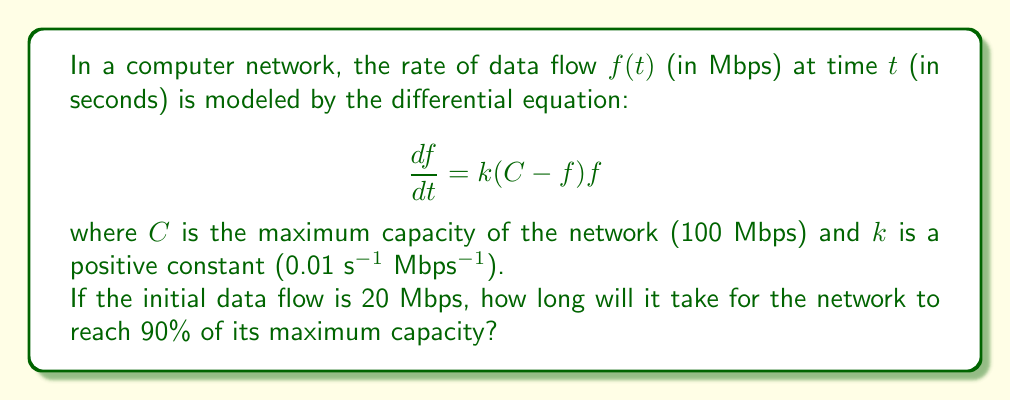Give your solution to this math problem. To solve this problem, we need to follow these steps:

1) First, we need to solve the differential equation. This is a logistic growth model.

2) The general solution to this equation is:

   $$f(t) = \frac{C}{1 + Ae^{-kCt}}$$

   where $A$ is a constant that depends on the initial condition.

3) We can find $A$ using the initial condition $f(0) = 20$:

   $$20 = \frac{100}{1 + A}$$
   $$A = 4$$

4) So our specific solution is:

   $$f(t) = \frac{100}{1 + 4e^{-t}}$$

   where we've substituted $k = 0.01$ and $C = 100$.

5) We want to find $t$ when $f(t) = 0.9C = 90$. So we solve:

   $$90 = \frac{100}{1 + 4e^{-t}}$$

6) Solving for $t$:

   $$1 + 4e^{-t} = \frac{100}{90} = \frac{10}{9}$$
   $$4e^{-t} = \frac{1}{9}$$
   $$e^{-t} = \frac{1}{36}$$
   $$-t = \ln(\frac{1}{36})$$
   $$t = \ln(36) \approx 3.58$$

7) Therefore, it will take approximately 3.58 seconds for the network to reach 90% of its maximum capacity.

This problem demonstrates how differential equations can be used to model and optimize network traffic flow, which is crucial for maintaining efficient data transfer in computer networks - a key concern for computer science departments looking to improve their infrastructure.
Answer: It will take approximately 3.58 seconds for the network to reach 90% of its maximum capacity. 